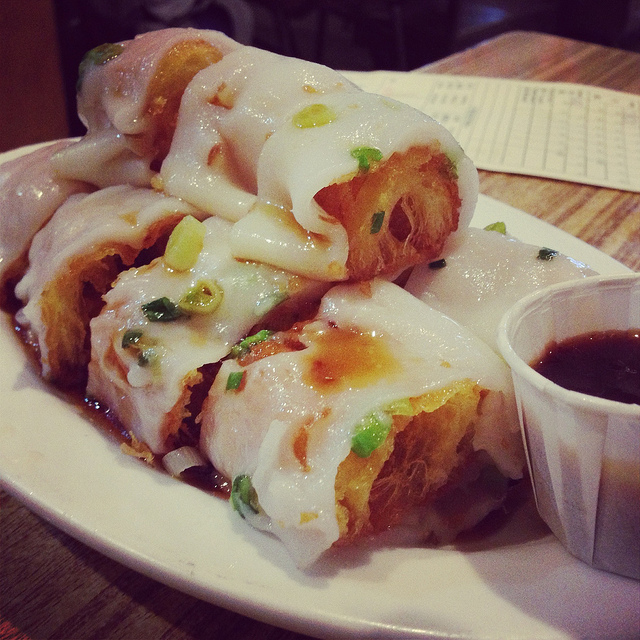<image>What is on this plate? I don't know what is exactly on the plate. It can be wrap, sushi or spring rolls. What is on this plate? I am not sure what is on the plate. It can be seen that there is some food, possibly sushi or spring rolls. 